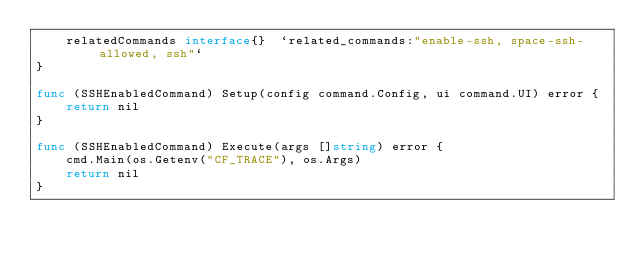<code> <loc_0><loc_0><loc_500><loc_500><_Go_>	relatedCommands interface{}  `related_commands:"enable-ssh, space-ssh-allowed, ssh"`
}

func (SSHEnabledCommand) Setup(config command.Config, ui command.UI) error {
	return nil
}

func (SSHEnabledCommand) Execute(args []string) error {
	cmd.Main(os.Getenv("CF_TRACE"), os.Args)
	return nil
}
</code> 